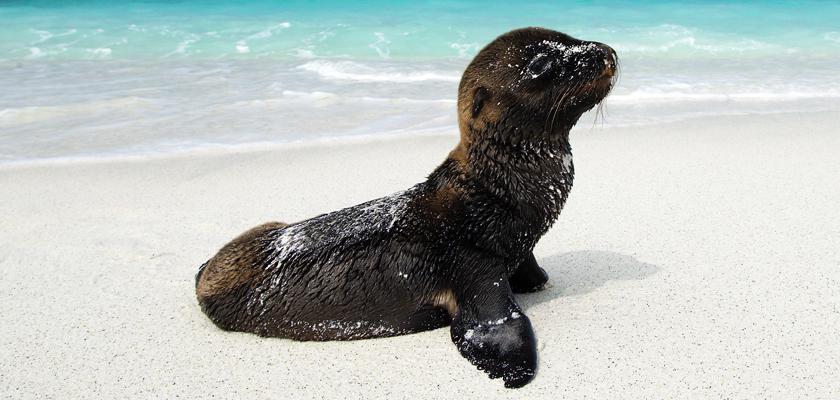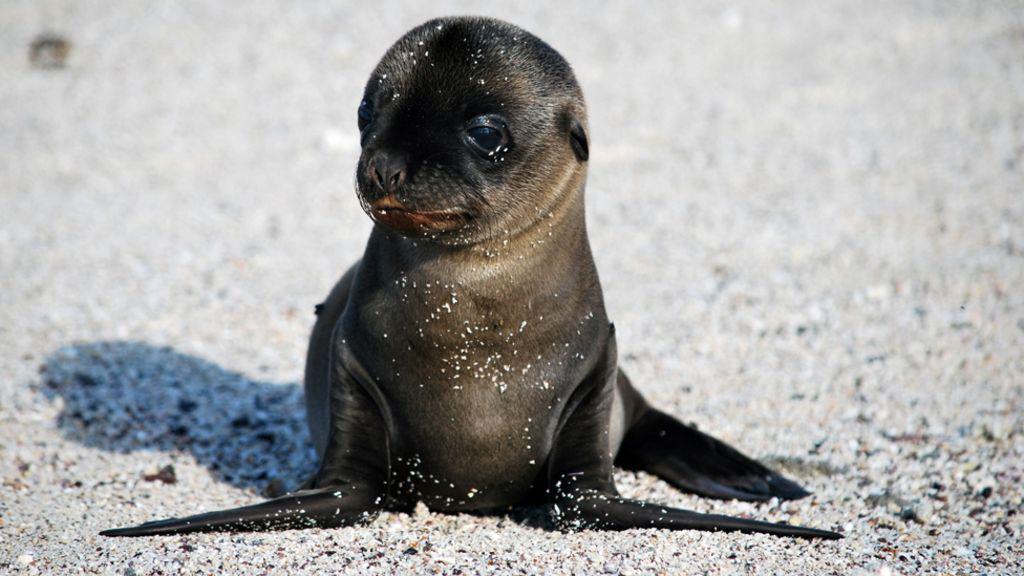The first image is the image on the left, the second image is the image on the right. Considering the images on both sides, is "The seals in the right and left images have their bodies turned in different [left vs right] directions, and no seals shown are babies." valid? Answer yes or no. No. The first image is the image on the left, the second image is the image on the right. Examine the images to the left and right. Is the description "There is one seal with a plain white background." accurate? Answer yes or no. No. 